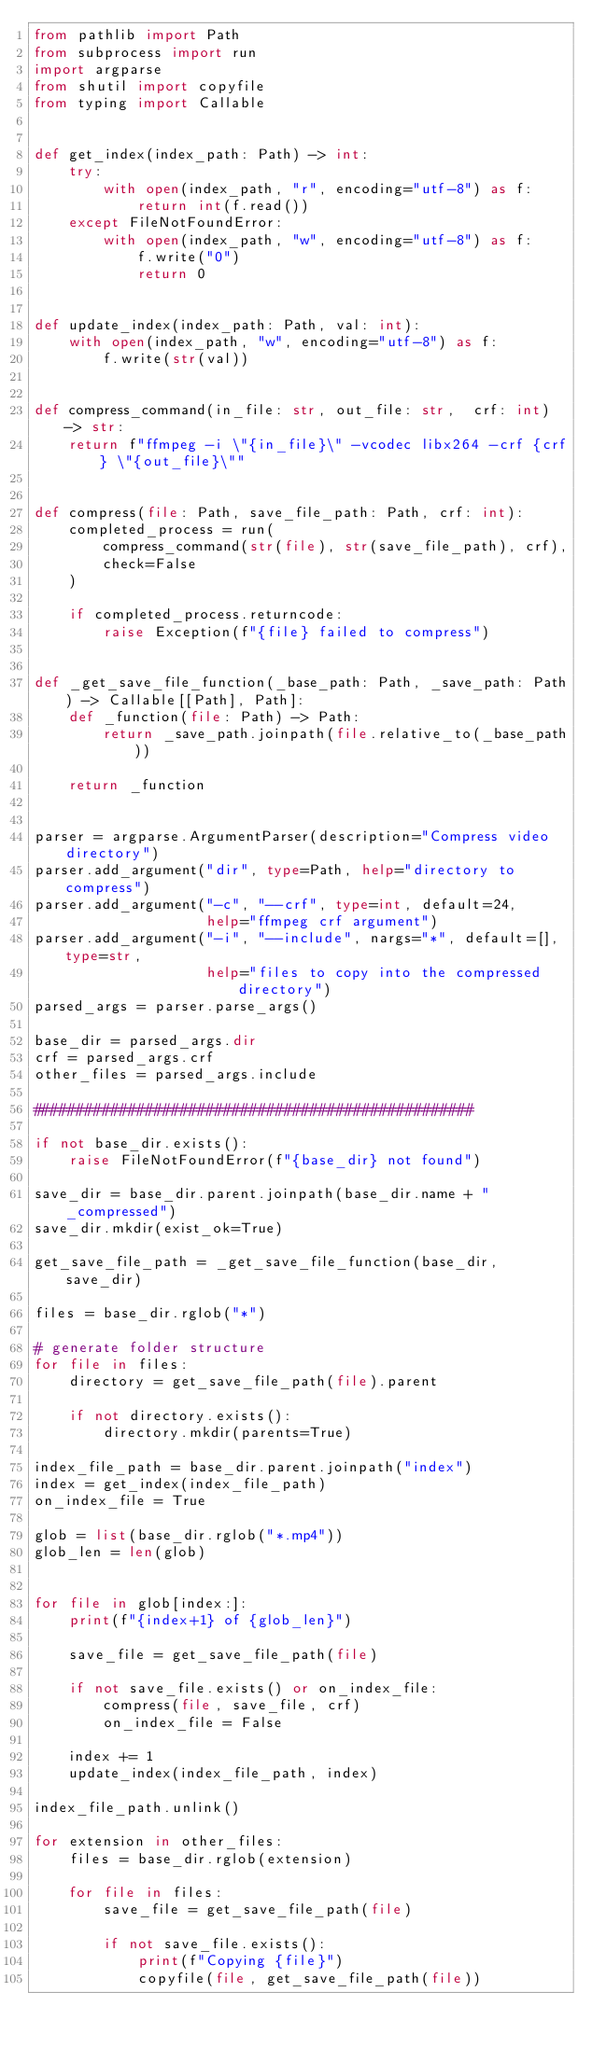<code> <loc_0><loc_0><loc_500><loc_500><_Python_>from pathlib import Path
from subprocess import run
import argparse
from shutil import copyfile
from typing import Callable


def get_index(index_path: Path) -> int:
    try:
        with open(index_path, "r", encoding="utf-8") as f:
            return int(f.read())
    except FileNotFoundError:
        with open(index_path, "w", encoding="utf-8") as f:
            f.write("0")
            return 0


def update_index(index_path: Path, val: int):
    with open(index_path, "w", encoding="utf-8") as f:
        f.write(str(val))


def compress_command(in_file: str, out_file: str,  crf: int) -> str:
    return f"ffmpeg -i \"{in_file}\" -vcodec libx264 -crf {crf} \"{out_file}\""


def compress(file: Path, save_file_path: Path, crf: int):
    completed_process = run(
        compress_command(str(file), str(save_file_path), crf),
        check=False
    )

    if completed_process.returncode:
        raise Exception(f"{file} failed to compress")


def _get_save_file_function(_base_path: Path, _save_path: Path) -> Callable[[Path], Path]:
    def _function(file: Path) -> Path:
        return _save_path.joinpath(file.relative_to(_base_path))

    return _function


parser = argparse.ArgumentParser(description="Compress video directory")
parser.add_argument("dir", type=Path, help="directory to compress")
parser.add_argument("-c", "--crf", type=int, default=24,
                    help="ffmpeg crf argument")
parser.add_argument("-i", "--include", nargs="*", default=[], type=str,
                    help="files to copy into the compressed directory")
parsed_args = parser.parse_args()

base_dir = parsed_args.dir
crf = parsed_args.crf
other_files = parsed_args.include

###################################################

if not base_dir.exists():
    raise FileNotFoundError(f"{base_dir} not found")

save_dir = base_dir.parent.joinpath(base_dir.name + "_compressed")
save_dir.mkdir(exist_ok=True)

get_save_file_path = _get_save_file_function(base_dir, save_dir)

files = base_dir.rglob("*")

# generate folder structure
for file in files:
    directory = get_save_file_path(file).parent

    if not directory.exists():
        directory.mkdir(parents=True)

index_file_path = base_dir.parent.joinpath("index")
index = get_index(index_file_path)
on_index_file = True

glob = list(base_dir.rglob("*.mp4"))
glob_len = len(glob)


for file in glob[index:]:
    print(f"{index+1} of {glob_len}")

    save_file = get_save_file_path(file)

    if not save_file.exists() or on_index_file:
        compress(file, save_file, crf)
        on_index_file = False

    index += 1
    update_index(index_file_path, index)

index_file_path.unlink()

for extension in other_files:
    files = base_dir.rglob(extension)

    for file in files:
        save_file = get_save_file_path(file)

        if not save_file.exists():
            print(f"Copying {file}")
            copyfile(file, get_save_file_path(file))
</code> 